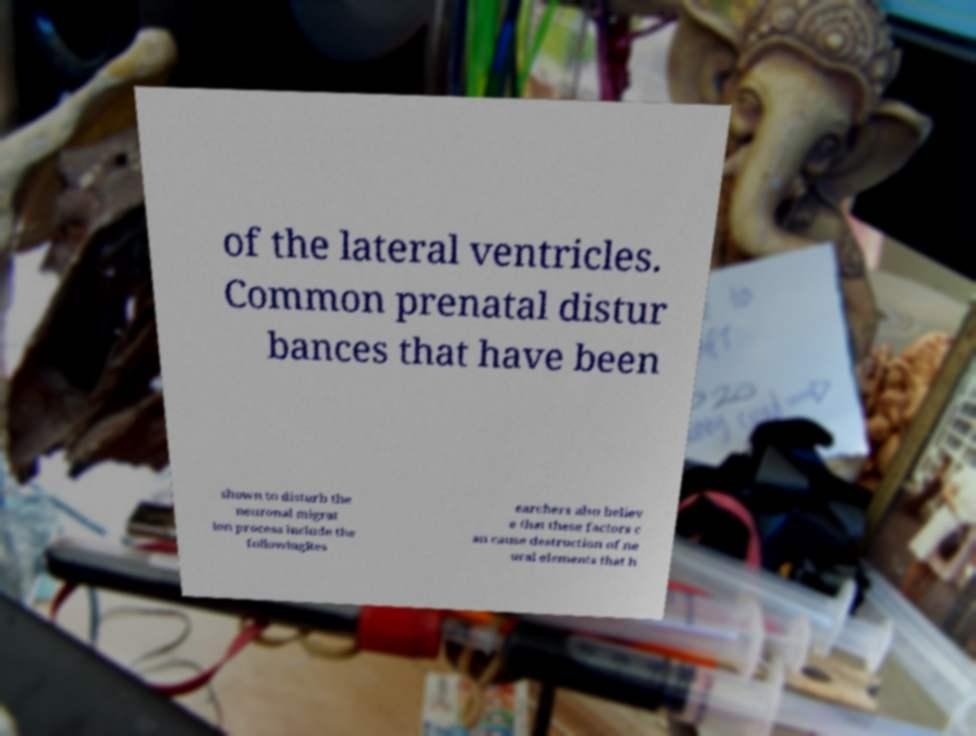Could you assist in decoding the text presented in this image and type it out clearly? of the lateral ventricles. Common prenatal distur bances that have been shown to disturb the neuronal migrat ion process include the followingRes earchers also believ e that these factors c an cause destruction of ne ural elements that h 